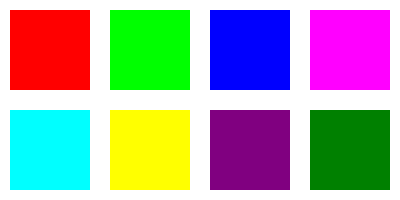You've just repainted a vintage dresser in a vibrant red color. Which color from the options shown would be the best complementary choice for repainting a matching nightstand? To determine the best complementary color for the red dresser, follow these steps:

1. Identify the color of the dresser: Vibrant red (top-left square in the image).

2. Recall the color wheel: Complementary colors are opposite each other on the color wheel.

3. The complement of red: Green is directly opposite red on the color wheel.

4. Examine the color options:
   - Top row: Red, Green, Blue, Magenta
   - Bottom row: Cyan, Yellow, Purple, Dark Green

5. Identify the green option: The green square is in the top row, second from the left.

6. Consider the context: As a complementary color, green will create a strong contrast with the red dresser, making both pieces stand out while maintaining a balanced and harmonious look in the room.

Therefore, the best complementary color choice for the nightstand to match the red dresser is green.
Answer: Green 